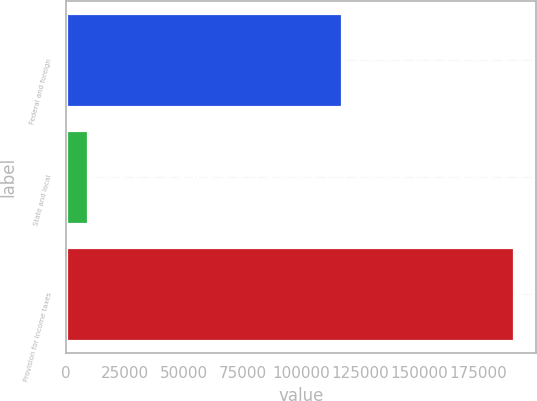Convert chart. <chart><loc_0><loc_0><loc_500><loc_500><bar_chart><fcel>Federal and foreign<fcel>State and local<fcel>Provision for income taxes<nl><fcel>117351<fcel>9453<fcel>190066<nl></chart> 